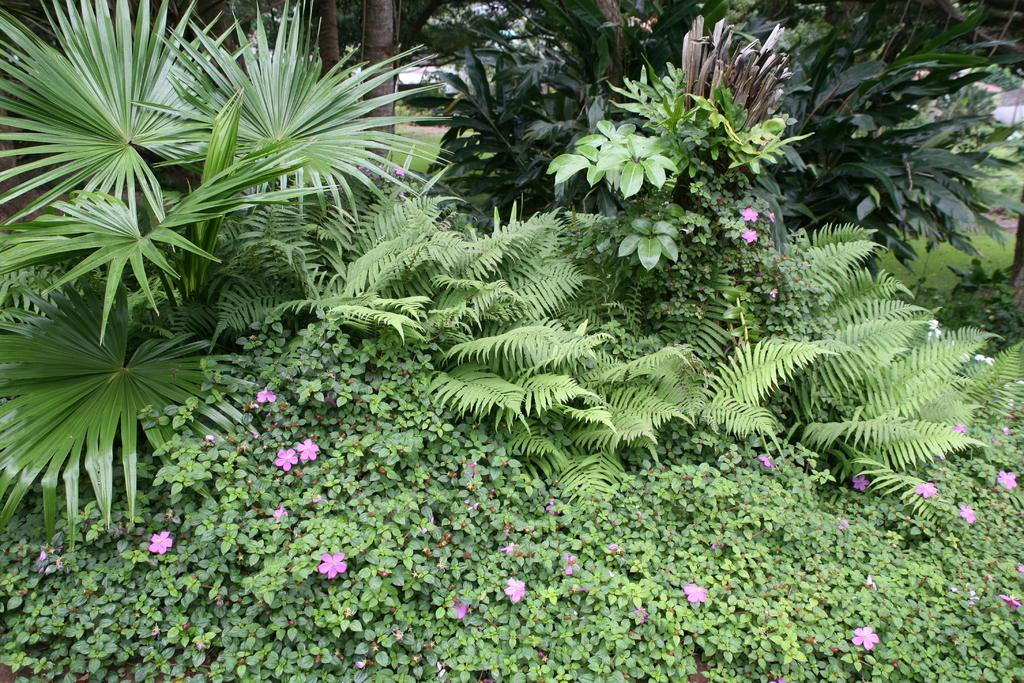What type of vegetation can be seen in the image? There are plants and flowers in the image. What is the ground covered with in the image? There is grass in the image. What type of can is visible in the image? There is no can present in the image; it features plants, flowers, and grass. What kind of plantation can be seen in the image? There is no plantation present in the image; it features plants, flowers, and grass in a natural setting. 